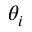<formula> <loc_0><loc_0><loc_500><loc_500>\theta _ { i }</formula> 